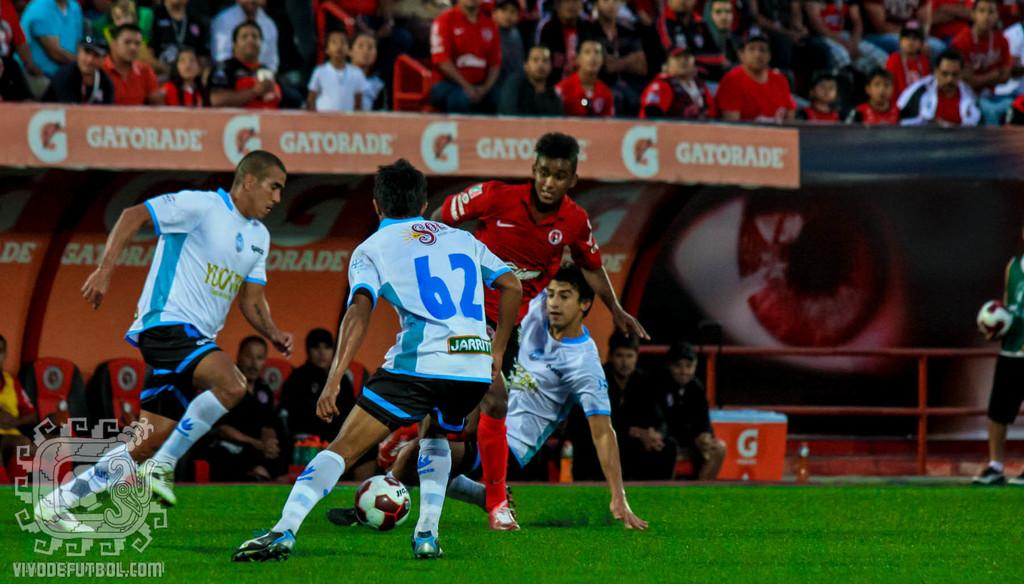<image>
Share a concise interpretation of the image provided. Soccer player wearing jersey number 62 about to steal a ball. 